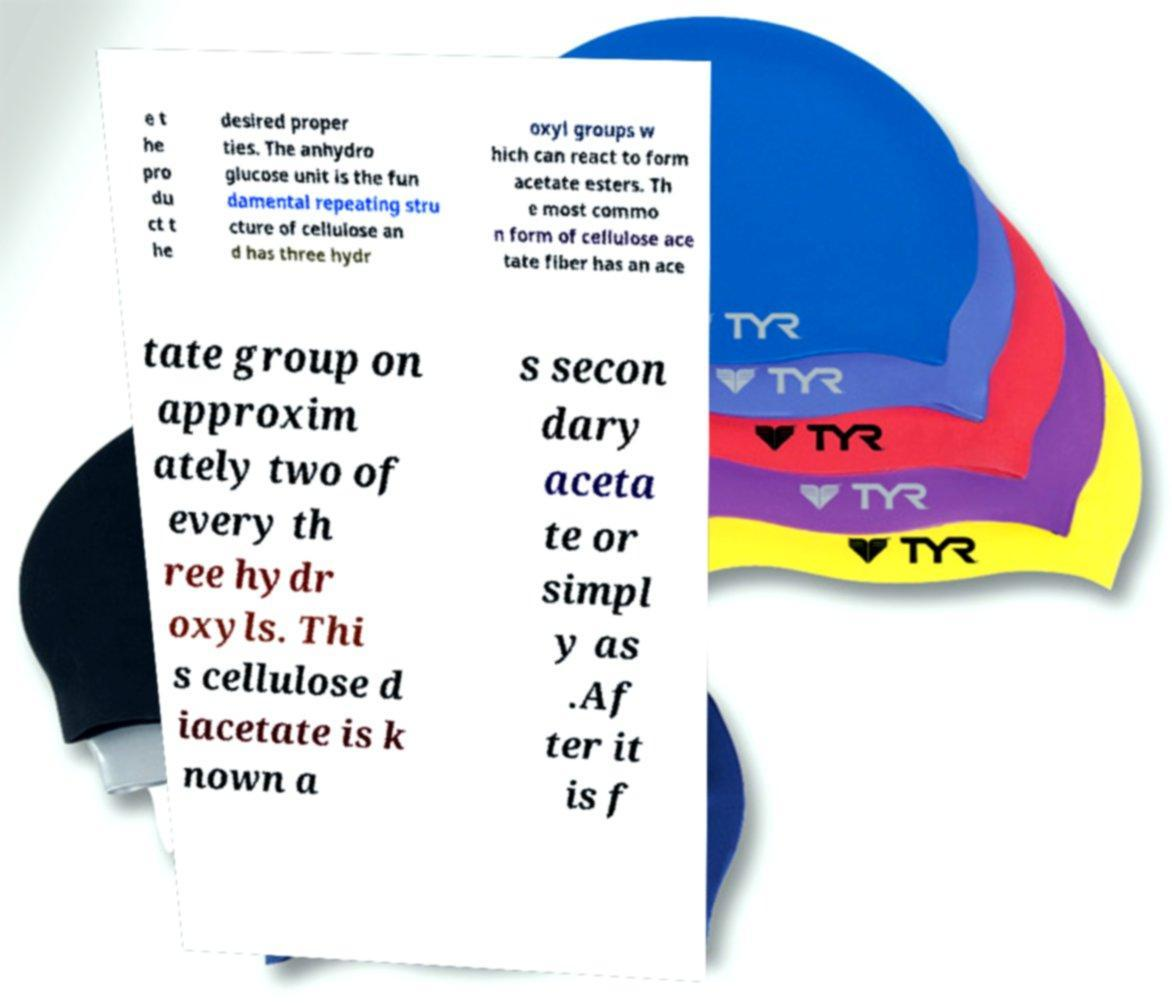Please identify and transcribe the text found in this image. e t he pro du ct t he desired proper ties. The anhydro glucose unit is the fun damental repeating stru cture of cellulose an d has three hydr oxyl groups w hich can react to form acetate esters. Th e most commo n form of cellulose ace tate fiber has an ace tate group on approxim ately two of every th ree hydr oxyls. Thi s cellulose d iacetate is k nown a s secon dary aceta te or simpl y as .Af ter it is f 